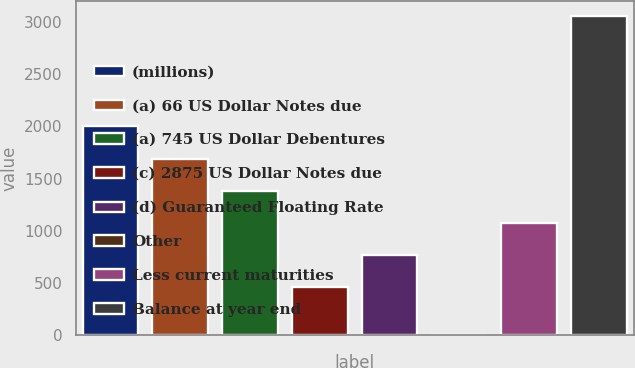Convert chart. <chart><loc_0><loc_0><loc_500><loc_500><bar_chart><fcel>(millions)<fcel>(a) 66 US Dollar Notes due<fcel>(a) 745 US Dollar Debentures<fcel>(c) 2875 US Dollar Notes due<fcel>(d) Guaranteed Floating Rate<fcel>Other<fcel>Less current maturities<fcel>Balance at year end<nl><fcel>2006<fcel>1683.56<fcel>1378.82<fcel>464.6<fcel>769.34<fcel>5.6<fcel>1074.08<fcel>3053<nl></chart> 